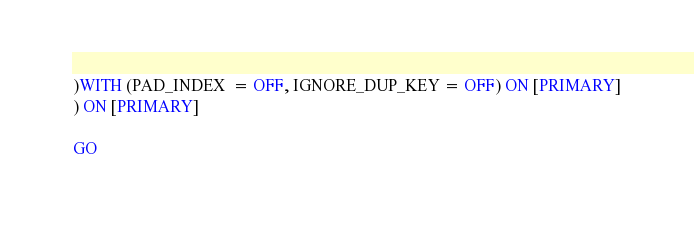Convert code to text. <code><loc_0><loc_0><loc_500><loc_500><_SQL_>)WITH (PAD_INDEX  = OFF, IGNORE_DUP_KEY = OFF) ON [PRIMARY]
) ON [PRIMARY]

GO</code> 